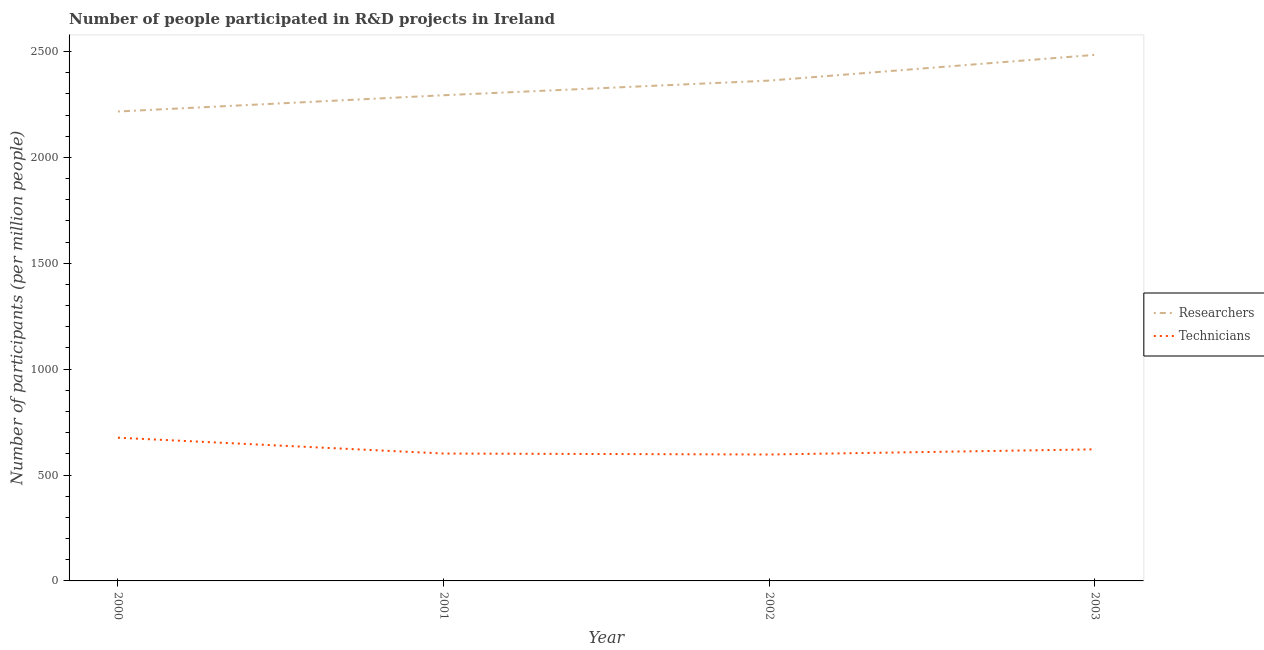Is the number of lines equal to the number of legend labels?
Your answer should be very brief. Yes. What is the number of technicians in 2003?
Provide a short and direct response. 621.38. Across all years, what is the maximum number of technicians?
Your answer should be very brief. 676.29. Across all years, what is the minimum number of technicians?
Your answer should be compact. 596.99. In which year was the number of researchers minimum?
Ensure brevity in your answer.  2000. What is the total number of technicians in the graph?
Your answer should be very brief. 2496.2. What is the difference between the number of technicians in 2001 and that in 2003?
Ensure brevity in your answer.  -19.85. What is the difference between the number of researchers in 2000 and the number of technicians in 2001?
Keep it short and to the point. 1615.27. What is the average number of technicians per year?
Provide a short and direct response. 624.05. In the year 2000, what is the difference between the number of technicians and number of researchers?
Provide a succinct answer. -1540.51. What is the ratio of the number of researchers in 2001 to that in 2003?
Your response must be concise. 0.92. Is the number of technicians in 2002 less than that in 2003?
Keep it short and to the point. Yes. Is the difference between the number of researchers in 2001 and 2003 greater than the difference between the number of technicians in 2001 and 2003?
Your answer should be very brief. No. What is the difference between the highest and the second highest number of researchers?
Offer a very short reply. 121.52. What is the difference between the highest and the lowest number of researchers?
Make the answer very short. 267.49. In how many years, is the number of researchers greater than the average number of researchers taken over all years?
Give a very brief answer. 2. Is the sum of the number of researchers in 2000 and 2001 greater than the maximum number of technicians across all years?
Provide a short and direct response. Yes. Does the number of researchers monotonically increase over the years?
Keep it short and to the point. Yes. Is the number of researchers strictly less than the number of technicians over the years?
Provide a short and direct response. No. How many lines are there?
Your response must be concise. 2. How many years are there in the graph?
Provide a succinct answer. 4. What is the difference between two consecutive major ticks on the Y-axis?
Your response must be concise. 500. Does the graph contain any zero values?
Provide a short and direct response. No. Where does the legend appear in the graph?
Provide a short and direct response. Center right. How many legend labels are there?
Your answer should be compact. 2. How are the legend labels stacked?
Keep it short and to the point. Vertical. What is the title of the graph?
Keep it short and to the point. Number of people participated in R&D projects in Ireland. Does "UN agencies" appear as one of the legend labels in the graph?
Offer a terse response. No. What is the label or title of the X-axis?
Your answer should be very brief. Year. What is the label or title of the Y-axis?
Provide a succinct answer. Number of participants (per million people). What is the Number of participants (per million people) of Researchers in 2000?
Give a very brief answer. 2216.8. What is the Number of participants (per million people) in Technicians in 2000?
Offer a terse response. 676.29. What is the Number of participants (per million people) in Researchers in 2001?
Give a very brief answer. 2293.62. What is the Number of participants (per million people) in Technicians in 2001?
Your response must be concise. 601.53. What is the Number of participants (per million people) of Researchers in 2002?
Make the answer very short. 2362.78. What is the Number of participants (per million people) in Technicians in 2002?
Give a very brief answer. 596.99. What is the Number of participants (per million people) in Researchers in 2003?
Keep it short and to the point. 2484.29. What is the Number of participants (per million people) of Technicians in 2003?
Provide a succinct answer. 621.38. Across all years, what is the maximum Number of participants (per million people) in Researchers?
Offer a terse response. 2484.29. Across all years, what is the maximum Number of participants (per million people) of Technicians?
Give a very brief answer. 676.29. Across all years, what is the minimum Number of participants (per million people) in Researchers?
Keep it short and to the point. 2216.8. Across all years, what is the minimum Number of participants (per million people) in Technicians?
Offer a very short reply. 596.99. What is the total Number of participants (per million people) of Researchers in the graph?
Offer a terse response. 9357.49. What is the total Number of participants (per million people) in Technicians in the graph?
Provide a short and direct response. 2496.2. What is the difference between the Number of participants (per million people) of Researchers in 2000 and that in 2001?
Your response must be concise. -76.82. What is the difference between the Number of participants (per million people) of Technicians in 2000 and that in 2001?
Your answer should be very brief. 74.75. What is the difference between the Number of participants (per million people) of Researchers in 2000 and that in 2002?
Provide a short and direct response. -145.98. What is the difference between the Number of participants (per million people) in Technicians in 2000 and that in 2002?
Ensure brevity in your answer.  79.29. What is the difference between the Number of participants (per million people) in Researchers in 2000 and that in 2003?
Provide a succinct answer. -267.5. What is the difference between the Number of participants (per million people) of Technicians in 2000 and that in 2003?
Your answer should be very brief. 54.9. What is the difference between the Number of participants (per million people) in Researchers in 2001 and that in 2002?
Provide a succinct answer. -69.15. What is the difference between the Number of participants (per million people) of Technicians in 2001 and that in 2002?
Make the answer very short. 4.54. What is the difference between the Number of participants (per million people) in Researchers in 2001 and that in 2003?
Offer a terse response. -190.67. What is the difference between the Number of participants (per million people) in Technicians in 2001 and that in 2003?
Ensure brevity in your answer.  -19.85. What is the difference between the Number of participants (per million people) of Researchers in 2002 and that in 2003?
Offer a very short reply. -121.52. What is the difference between the Number of participants (per million people) of Technicians in 2002 and that in 2003?
Keep it short and to the point. -24.39. What is the difference between the Number of participants (per million people) in Researchers in 2000 and the Number of participants (per million people) in Technicians in 2001?
Your answer should be compact. 1615.27. What is the difference between the Number of participants (per million people) in Researchers in 2000 and the Number of participants (per million people) in Technicians in 2002?
Ensure brevity in your answer.  1619.81. What is the difference between the Number of participants (per million people) in Researchers in 2000 and the Number of participants (per million people) in Technicians in 2003?
Offer a very short reply. 1595.42. What is the difference between the Number of participants (per million people) in Researchers in 2001 and the Number of participants (per million people) in Technicians in 2002?
Provide a succinct answer. 1696.63. What is the difference between the Number of participants (per million people) in Researchers in 2001 and the Number of participants (per million people) in Technicians in 2003?
Make the answer very short. 1672.24. What is the difference between the Number of participants (per million people) of Researchers in 2002 and the Number of participants (per million people) of Technicians in 2003?
Offer a very short reply. 1741.39. What is the average Number of participants (per million people) in Researchers per year?
Provide a succinct answer. 2339.37. What is the average Number of participants (per million people) in Technicians per year?
Provide a short and direct response. 624.05. In the year 2000, what is the difference between the Number of participants (per million people) of Researchers and Number of participants (per million people) of Technicians?
Keep it short and to the point. 1540.51. In the year 2001, what is the difference between the Number of participants (per million people) of Researchers and Number of participants (per million people) of Technicians?
Keep it short and to the point. 1692.09. In the year 2002, what is the difference between the Number of participants (per million people) of Researchers and Number of participants (per million people) of Technicians?
Offer a terse response. 1765.78. In the year 2003, what is the difference between the Number of participants (per million people) of Researchers and Number of participants (per million people) of Technicians?
Provide a succinct answer. 1862.91. What is the ratio of the Number of participants (per million people) of Researchers in 2000 to that in 2001?
Provide a succinct answer. 0.97. What is the ratio of the Number of participants (per million people) in Technicians in 2000 to that in 2001?
Ensure brevity in your answer.  1.12. What is the ratio of the Number of participants (per million people) in Researchers in 2000 to that in 2002?
Your response must be concise. 0.94. What is the ratio of the Number of participants (per million people) in Technicians in 2000 to that in 2002?
Your answer should be compact. 1.13. What is the ratio of the Number of participants (per million people) of Researchers in 2000 to that in 2003?
Your answer should be compact. 0.89. What is the ratio of the Number of participants (per million people) of Technicians in 2000 to that in 2003?
Give a very brief answer. 1.09. What is the ratio of the Number of participants (per million people) in Researchers in 2001 to that in 2002?
Offer a terse response. 0.97. What is the ratio of the Number of participants (per million people) in Technicians in 2001 to that in 2002?
Offer a terse response. 1.01. What is the ratio of the Number of participants (per million people) of Researchers in 2001 to that in 2003?
Keep it short and to the point. 0.92. What is the ratio of the Number of participants (per million people) of Technicians in 2001 to that in 2003?
Your answer should be compact. 0.97. What is the ratio of the Number of participants (per million people) in Researchers in 2002 to that in 2003?
Provide a short and direct response. 0.95. What is the ratio of the Number of participants (per million people) in Technicians in 2002 to that in 2003?
Provide a succinct answer. 0.96. What is the difference between the highest and the second highest Number of participants (per million people) in Researchers?
Your response must be concise. 121.52. What is the difference between the highest and the second highest Number of participants (per million people) in Technicians?
Give a very brief answer. 54.9. What is the difference between the highest and the lowest Number of participants (per million people) of Researchers?
Provide a succinct answer. 267.5. What is the difference between the highest and the lowest Number of participants (per million people) in Technicians?
Your answer should be compact. 79.29. 